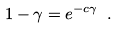Convert formula to latex. <formula><loc_0><loc_0><loc_500><loc_500>1 - \gamma = e ^ { - c \gamma } \ .</formula> 